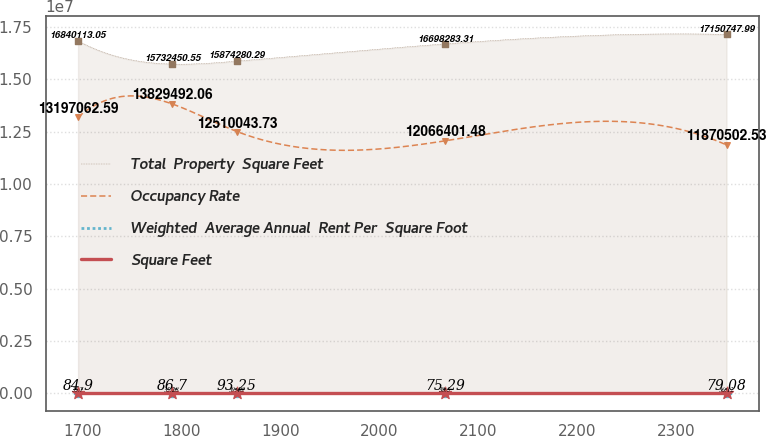Convert chart to OTSL. <chart><loc_0><loc_0><loc_500><loc_500><line_chart><ecel><fcel>Total  Property  Square Feet<fcel>Occupancy Rate<fcel>Weighted  Average Annual  Rent Per  Square Foot<fcel>Square Feet<nl><fcel>1695.64<fcel>1.68401e+07<fcel>1.31971e+07<fcel>84.9<fcel>35.7<nl><fcel>1790.64<fcel>1.57325e+07<fcel>1.38295e+07<fcel>86.7<fcel>35.28<nl><fcel>1856.12<fcel>1.58743e+07<fcel>1.251e+07<fcel>93.25<fcel>39.48<nl><fcel>2066.37<fcel>1.66983e+07<fcel>1.20664e+07<fcel>75.29<fcel>38.5<nl><fcel>2350.47<fcel>1.71507e+07<fcel>1.18705e+07<fcel>79.08<fcel>36.12<nl></chart> 